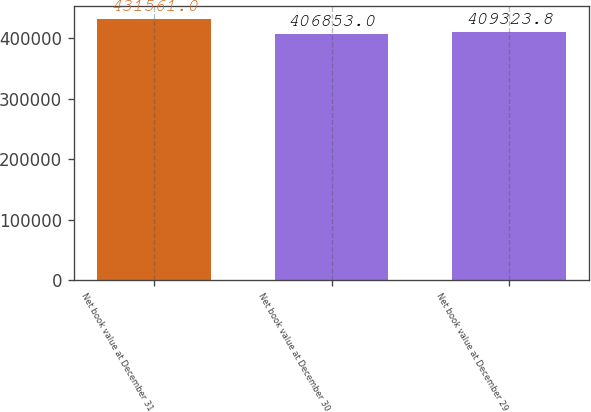Convert chart. <chart><loc_0><loc_0><loc_500><loc_500><bar_chart><fcel>Net book value at December 31<fcel>Net book value at December 30<fcel>Net book value at December 29<nl><fcel>431561<fcel>406853<fcel>409324<nl></chart> 